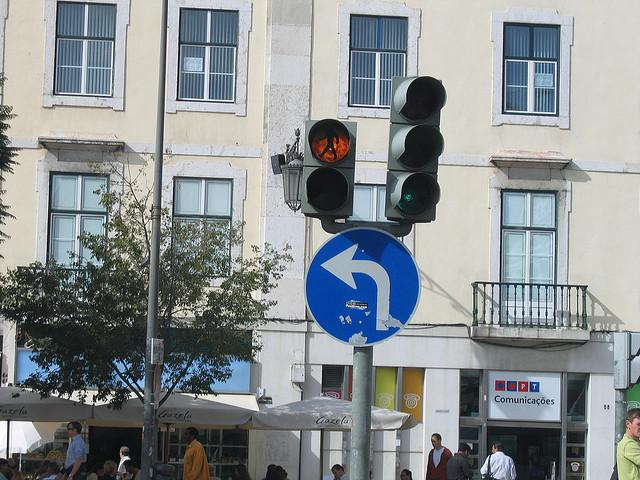What is the sign telling drivers? turn left 